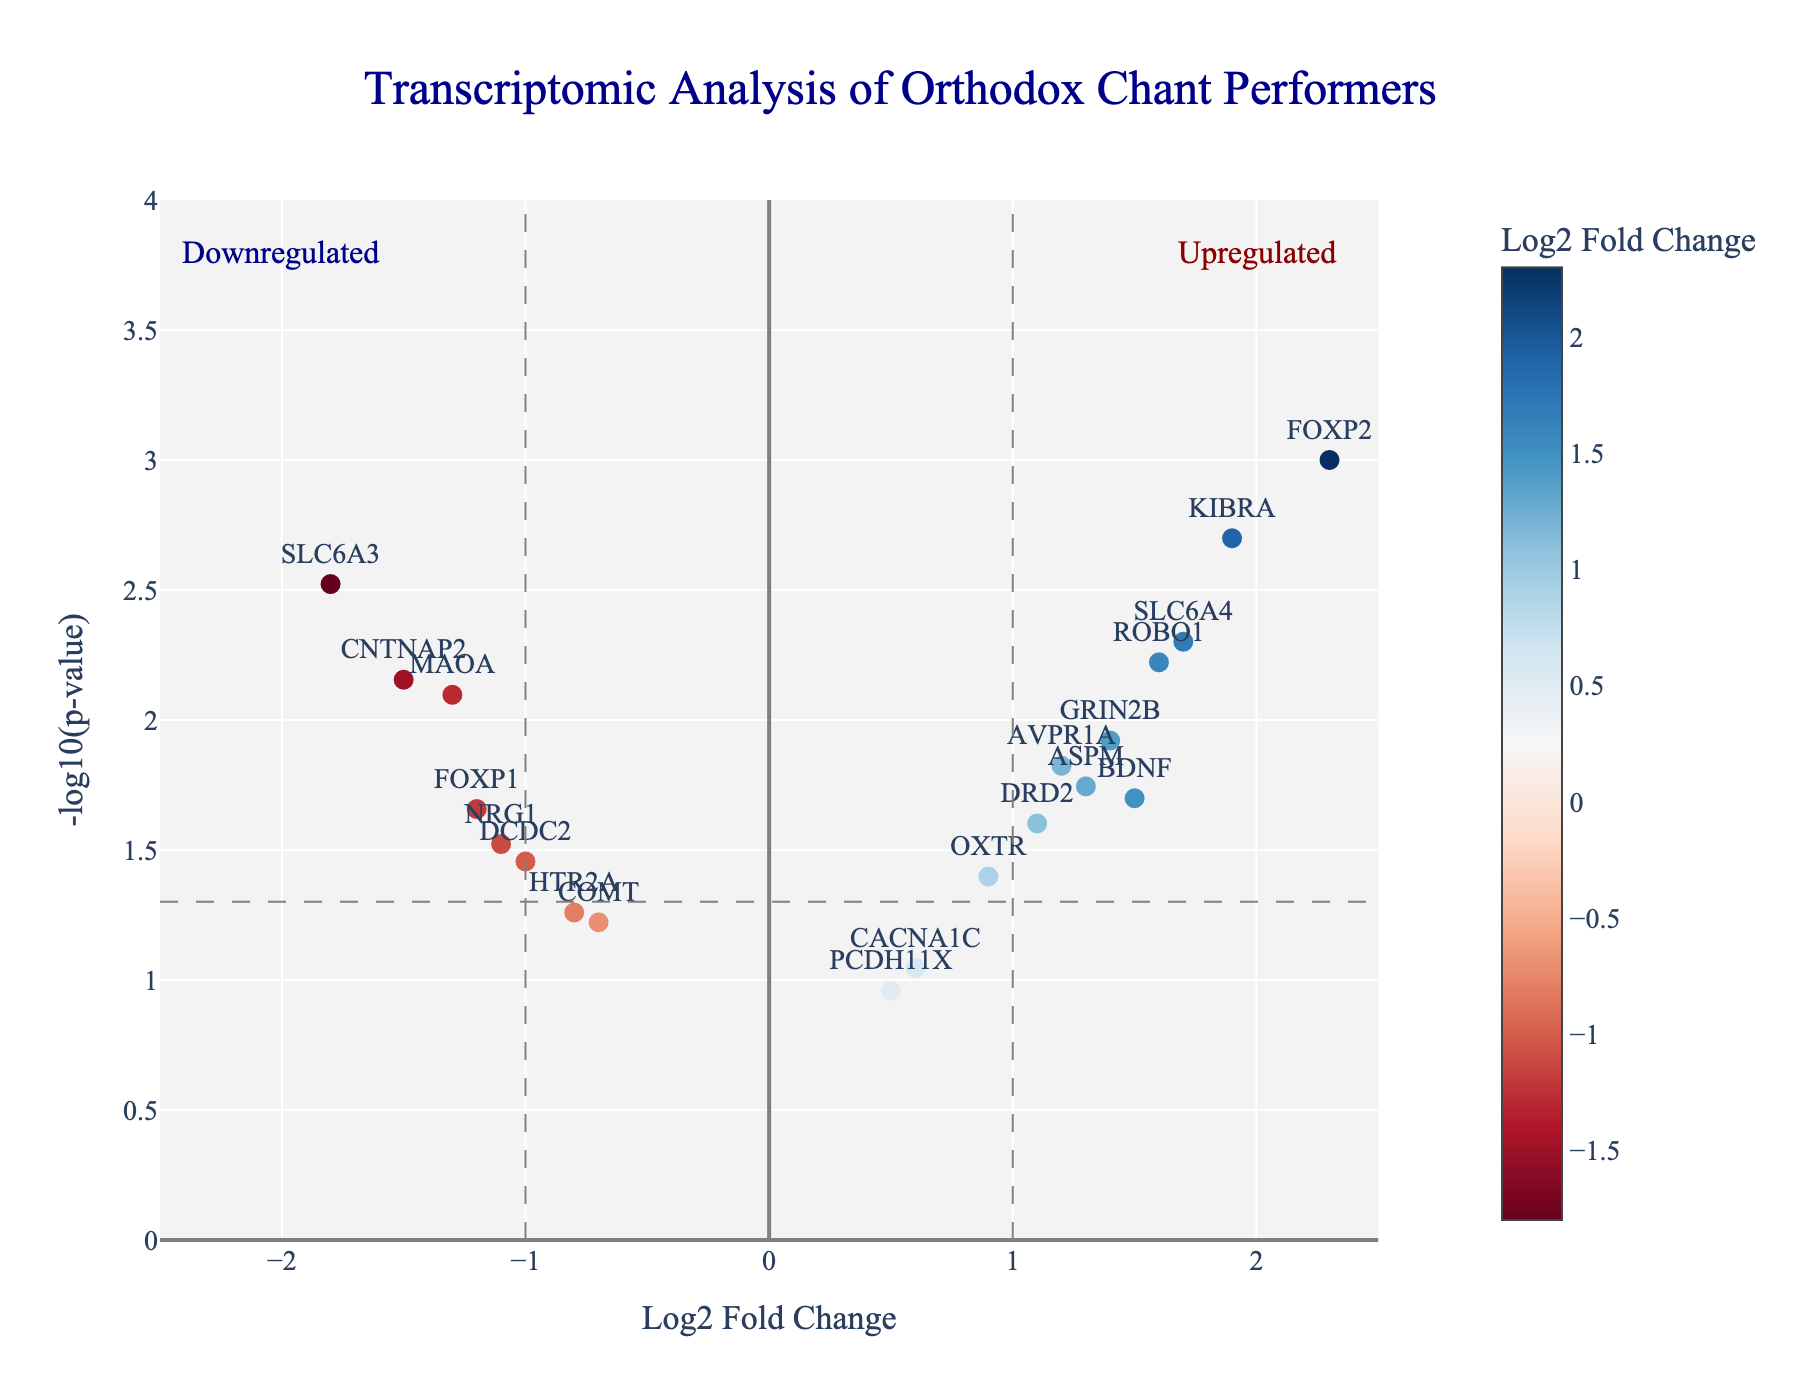What is the title of the plot? The title of the plot is directly visible at the top. It reads "Transcriptomic Analysis of Orthodox Chant Performers."
Answer: Transcriptomic Analysis of Orthodox Chant Performers What are the labels of the x-axis and y-axis? The axis labels are located along the axes. The x-axis label is "Log2 Fold Change," and the y-axis label is "-log10(p-value)."
Answer: x-axis: Log2 Fold Change, y-axis: -log10(p-value) How many genes are significantly upregulated at -log10(p-value) > 1.3 and Log2 Fold Change > 1? To determine the number of significantly upregulated genes, look for the points above the horizontal grey line at -log10(p-value)=1.3 and to the right of the vertical grey line at Log2 Fold Change=1. Counting these points, there are 7 genes (FOXP2, BDNF, AVPR1A, SLC6A4, GRIN2B, KIBRA, ROBO1).
Answer: 7 genes Which gene has the highest -log10(p-value) and what is its value? By observing the data points, FOXP2 is the highest on the y-axis, indicating the largest -log10(p-value). The value of FOXP2’s -log10(p-value) can be found by its location or approximately given its p-value in the data (-log10(0.001) ≈ 3).
Answer: FOXP2, 3 Compare the Log2 Fold Change of FOXP2 and SLC6A3. Which one is higher and by how much? FOXP2 has a Log2 Fold Change of 2.3, and SLC6A3 has -1.8. Subtracting these values gives 2.3 - (-1.8) = 2.3 + 1.8 = 4.1, indicating FOXP2’s Log2 Fold Change is higher by 4.1 units.
Answer: FOXP2, higher by 4.1 Which data points fall in the downregulated region with significant p-values (Log2 Fold Change < -1 and -log10(p-value) > 1.3)? In the left area below the vertical line at Log2 Fold Change = -1 and above the horizontal line at -log10(p-value)= 1.3 are SLC6A3, MAOA, CNTNAP2, and FOXP1.
Answer: SLC6A3, MAOA, CNTNAP2, FOXP1 What does the vertical grey dashed line at Log2 Fold Change = 1 represent? The vertical grey dashed line at Log2 Fold Change = 1 represents a threshold separating genes with more than a two-fold increase (upregulated genes) from those with less change.
Answer: Threshold for upregulated genes What two genes fall on either side of the horizontal grey line (-log10(p-value) ≈ 1.3) but have comparable Log2 Fold Changes? AVPR1A and DRD2 have comparable Log2 Fold Changes around 1.2 and 1.1 respectively, but AVPR1A is slightly above -log10(p-value) ≈ 1.3 and DRD2 is slightly below.
Answer: AVPR1A, DRD2 